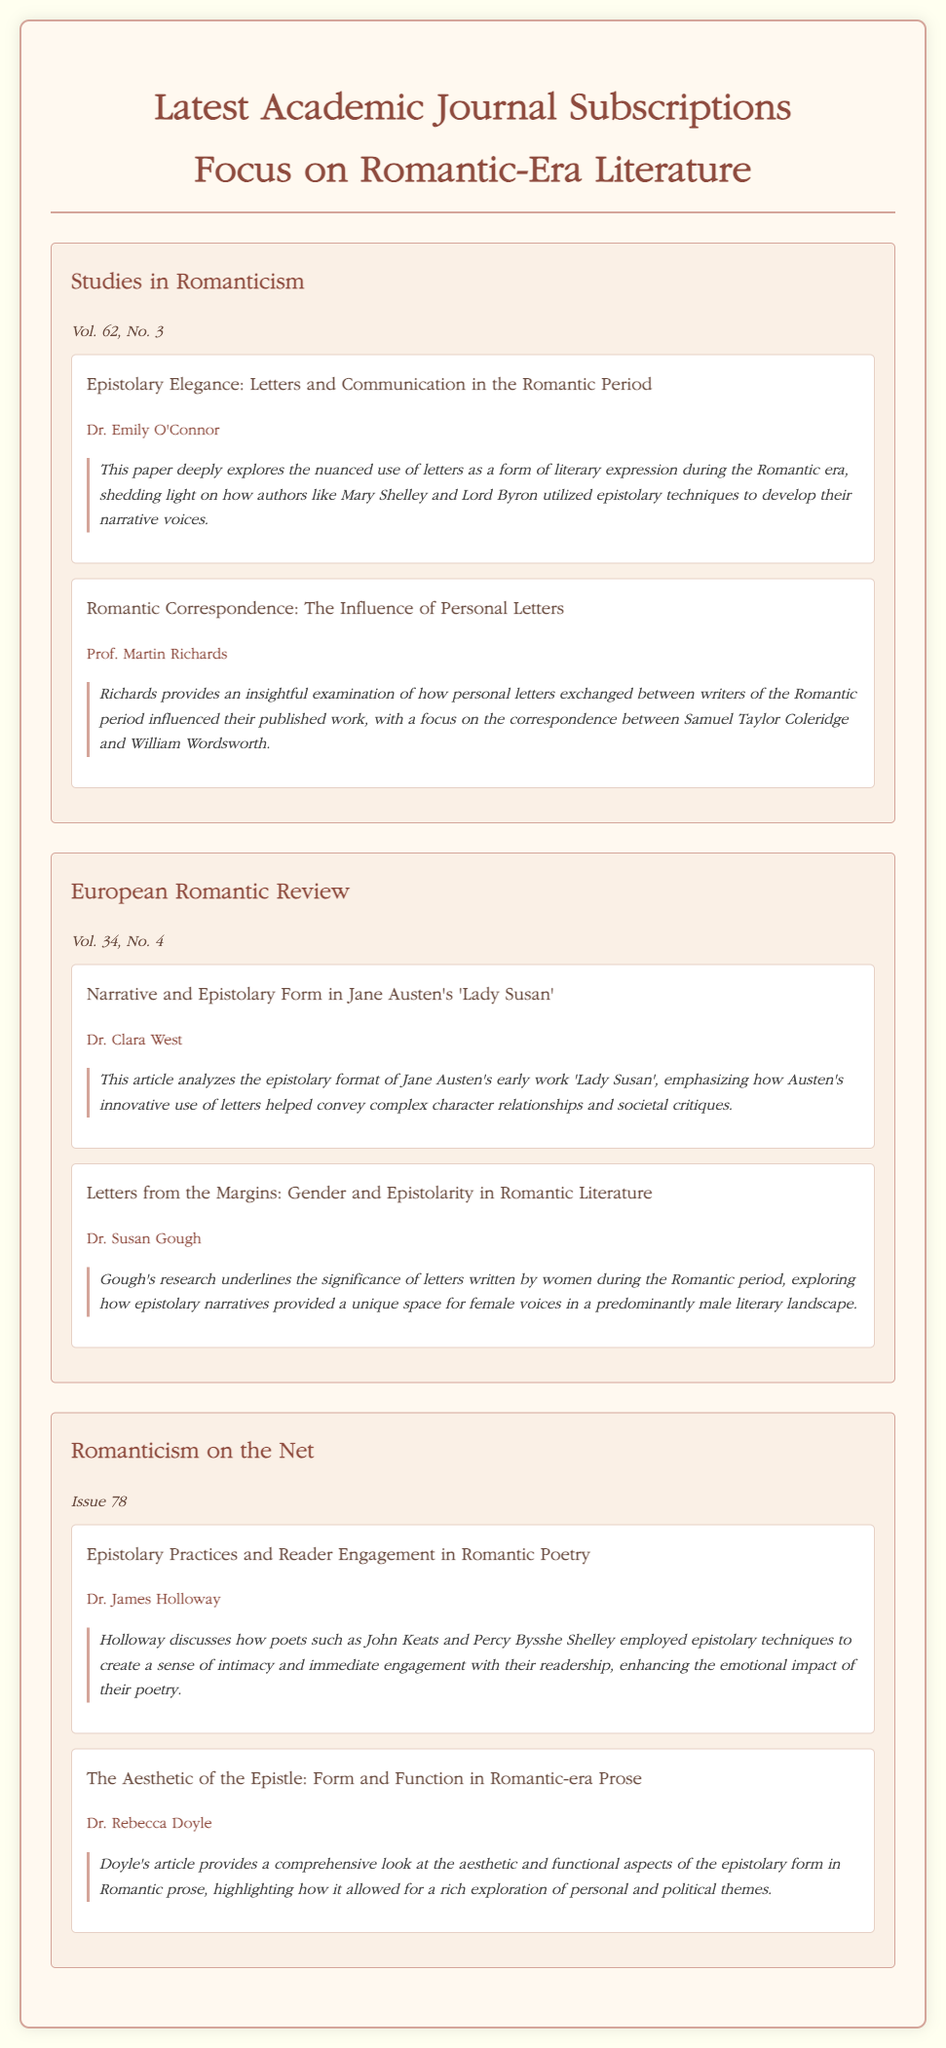What is the title of the first journal listed? The title of the first journal can be found in the section dedicated to the latest subscriptions, which states "Studies in Romanticism".
Answer: Studies in Romanticism Who authored the article "Letters from the Margins: Gender and Epistolarity in Romantic Literature"? The author of this article is indicated next to the title, which mentions "Dr. Susan Gough".
Answer: Dr. Susan Gough In which volume can you find "Romantic Correspondence: The Influence of Personal Letters"? The volume number is included in the journal information of the article, stating "Vol. 62, No. 3."
Answer: Vol. 62, No. 3 What is the main topic of the article by Dr. Emily O'Connor? The annotation describes the focus of the article, which includes "the nuanced use of letters as a form of literary expression during the Romantic era".
Answer: Literary expression How many articles are there in the "European Romantic Review"? By counting the articles listed under this journal section, one can find there are two articles.
Answer: 2 What is the issue number for "Romanticism on the Net"? The issue number is specified in the journal information stating "Issue 78".
Answer: Issue 78 Which journal features an article about Jane Austen's 'Lady Susan'? The article's title and author point to the journal section that states "European Romantic Review".
Answer: European Romantic Review What unique aspect do Gough's research findings highlight? Gough's research emphasizes "the significance of letters written by women during the Romantic period".
Answer: Female voices What does Dr. James Holloway discuss in his article? Holloway's article annotation mentions how poets "employed epistolary techniques to create a sense of intimacy".
Answer: Reader engagement 